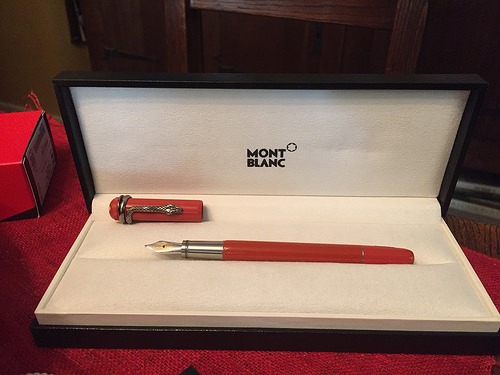<image>
Is there a pen in front of the box? No. The pen is not in front of the box. The spatial positioning shows a different relationship between these objects. 